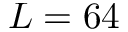Convert formula to latex. <formula><loc_0><loc_0><loc_500><loc_500>L = 6 4</formula> 